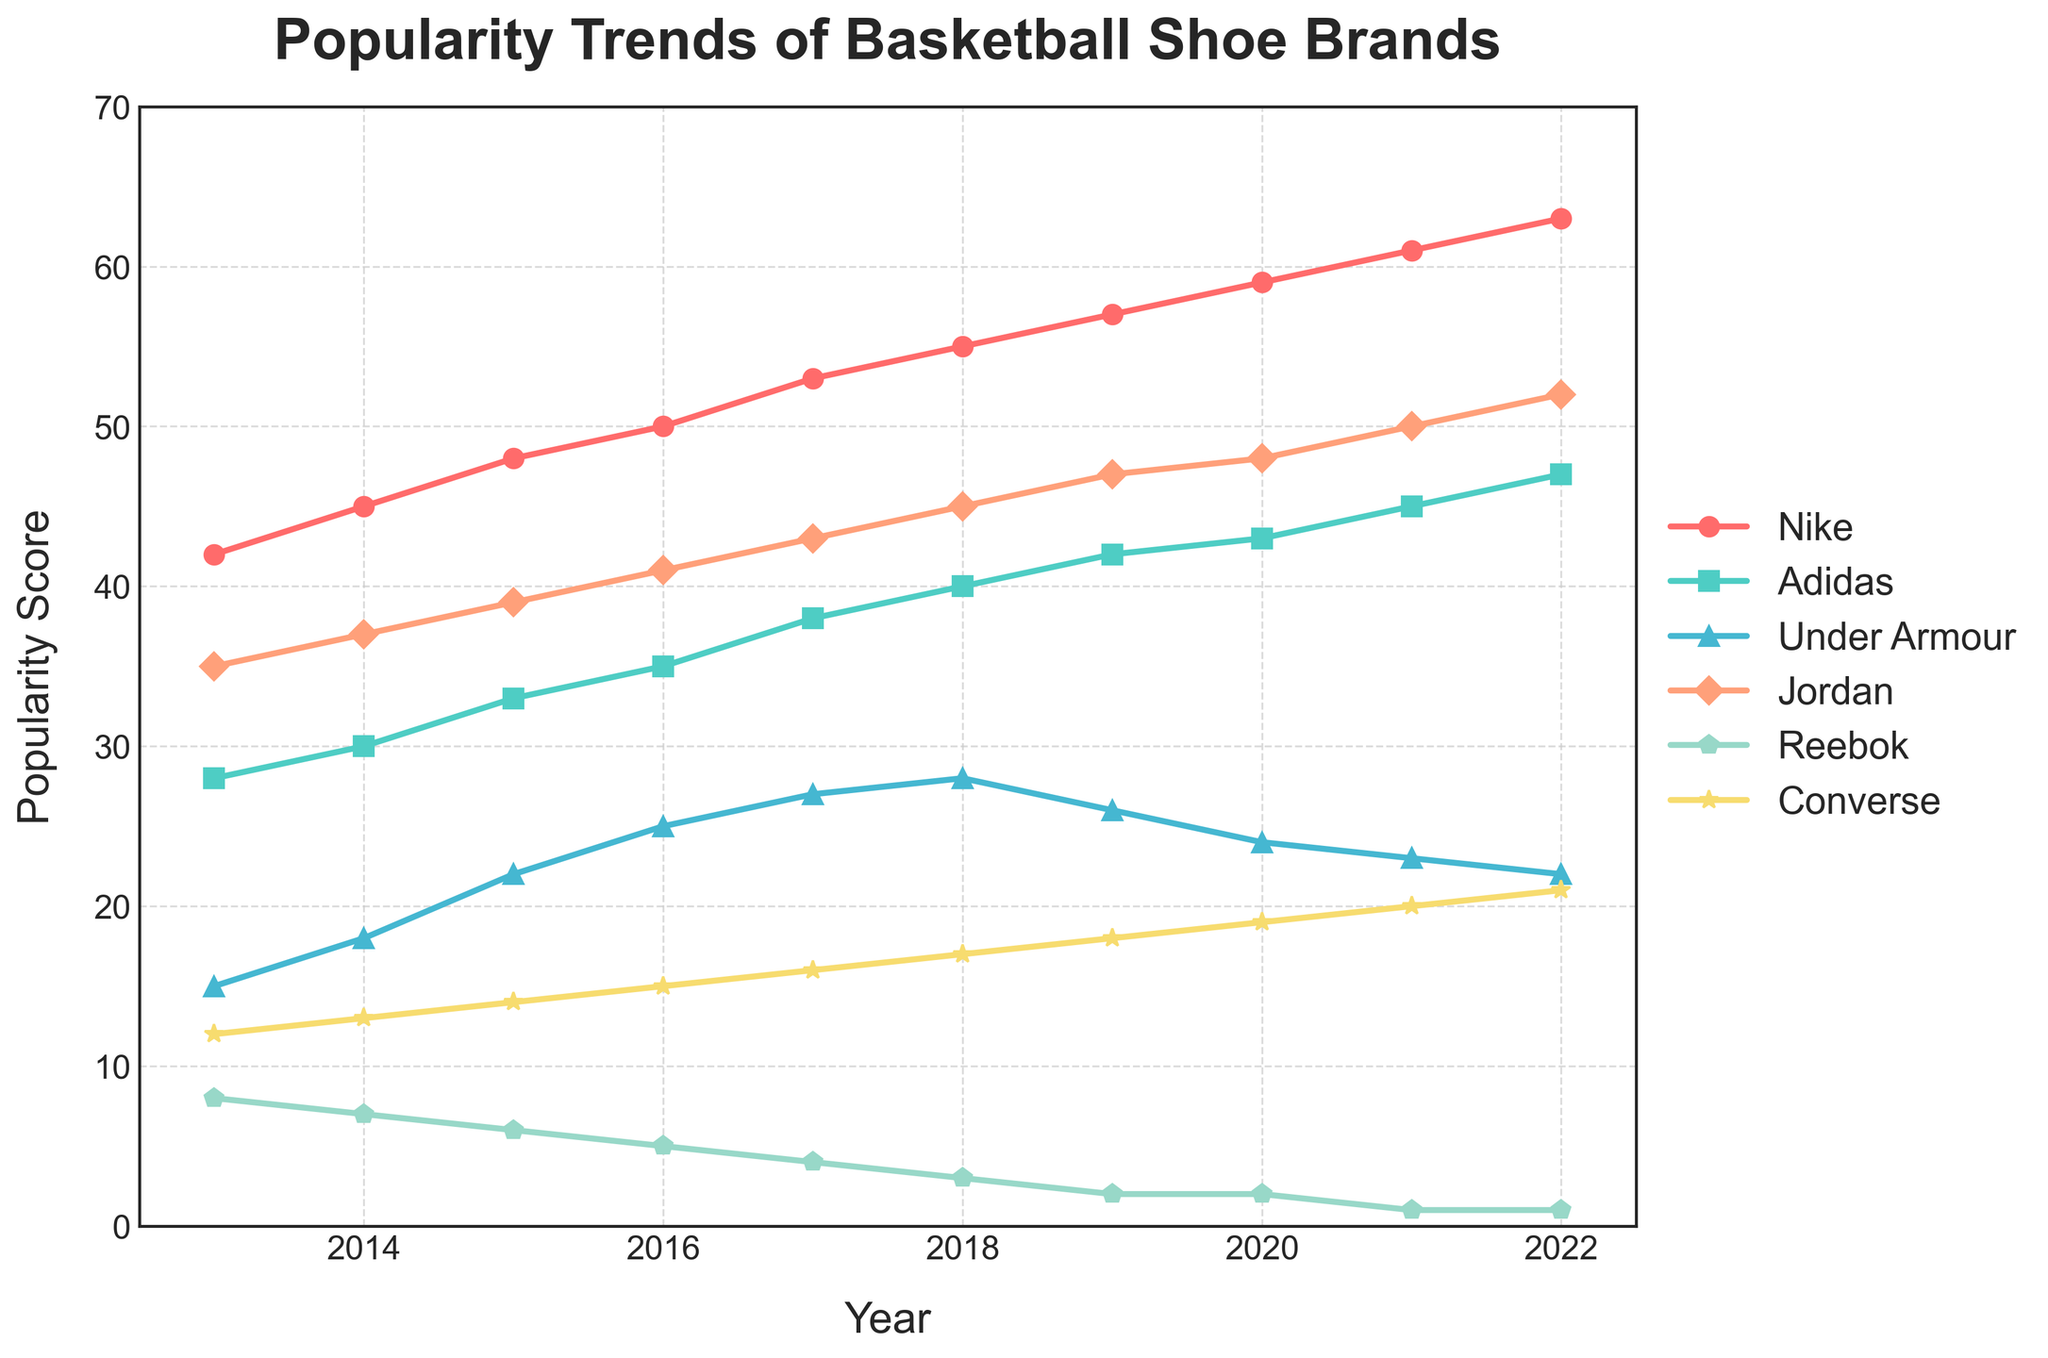what is the most popular basketball shoe brand in 2022? The figure shows the popularity trends of various shoe brands over the years. For the year 2022, the brand with the highest popularity score is Nike.
Answer: Nike Which brand's popularity showed the most consistent increase over the decade? To determine which brand's popularity increased most consistently, observe the lines' slopes in the figure. Nike's line shows a steady upward trend every year from 2013 to 2022, indicating a consistent increase.
Answer: Nike For which year did Under Armour reach its peak popularity in the given decade? Under Armour's highest point on the plot can be seen between 2013 to 2022. According to the plot, Under Armour peaked in popularity in the year 2018, where it scored 28.
Answer: 2018 How did the popularity of Reebok change from 2013 to 2022? Reebok's line in the figure will show the change in its popularity score over the years. Observing the trend, Reebok's popularity decreased from 8 in 2013 to 1 in 2022.
Answer: Decreased Which brand had a declining trend in popularity and ended with a score of 2 or less by 2022? By 2022, the brands with scores of 2 or less are Reebok and Converse. Observing the trend lines, Reebok consistently declined to a score of 1, and Converse showed a slight decline and ended at 2.
Answer: Reebok and Converse What major change happened to Jordan's popularity between 2019 and 2020? Look at the Jordan line plot between 2019 to 2020. There is an upward change as the score increases from 47 in 2019 to 48 in 2020.
Answer: Increased What was the combined popularity score of the top three brands in 2022? Identify the top three brands in 2022: Nike (63), Jordan (52), Adidas (47). Their combined score is 63 + 52 + 47 = 162.
Answer: 162 In which year did Adidas surpass Under Armour in popularity? Compare the Adidas and Under Armour trend lines. Adidas surpassed Under Armour in the year 2016, when Adidas scored 35 and Under Armour 25.
Answer: 2016 Calculate the average popularity score of Converse over the decade. Sum the yearly scores of Converse from 2013 to 2022: (12 + 13 + 14 + 15 + 16 + 17 + 18 + 19 + 20 + 21) = 165. Divide by the number of years, 10: 165/10 = 16.5.
Answer: 16.5 